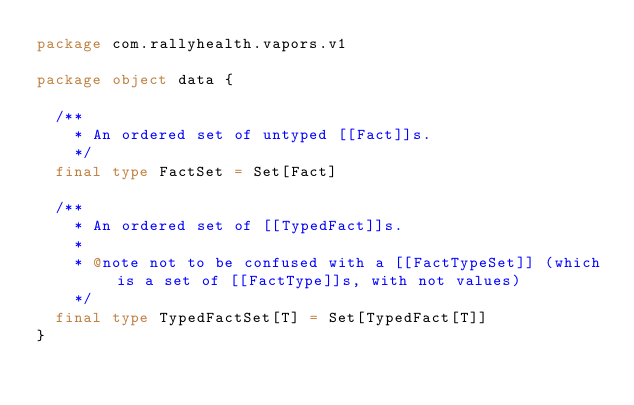<code> <loc_0><loc_0><loc_500><loc_500><_Scala_>package com.rallyhealth.vapors.v1

package object data {

  /**
    * An ordered set of untyped [[Fact]]s.
    */
  final type FactSet = Set[Fact]

  /**
    * An ordered set of [[TypedFact]]s.
    *
    * @note not to be confused with a [[FactTypeSet]] (which is a set of [[FactType]]s, with not values)
    */
  final type TypedFactSet[T] = Set[TypedFact[T]]
}
</code> 